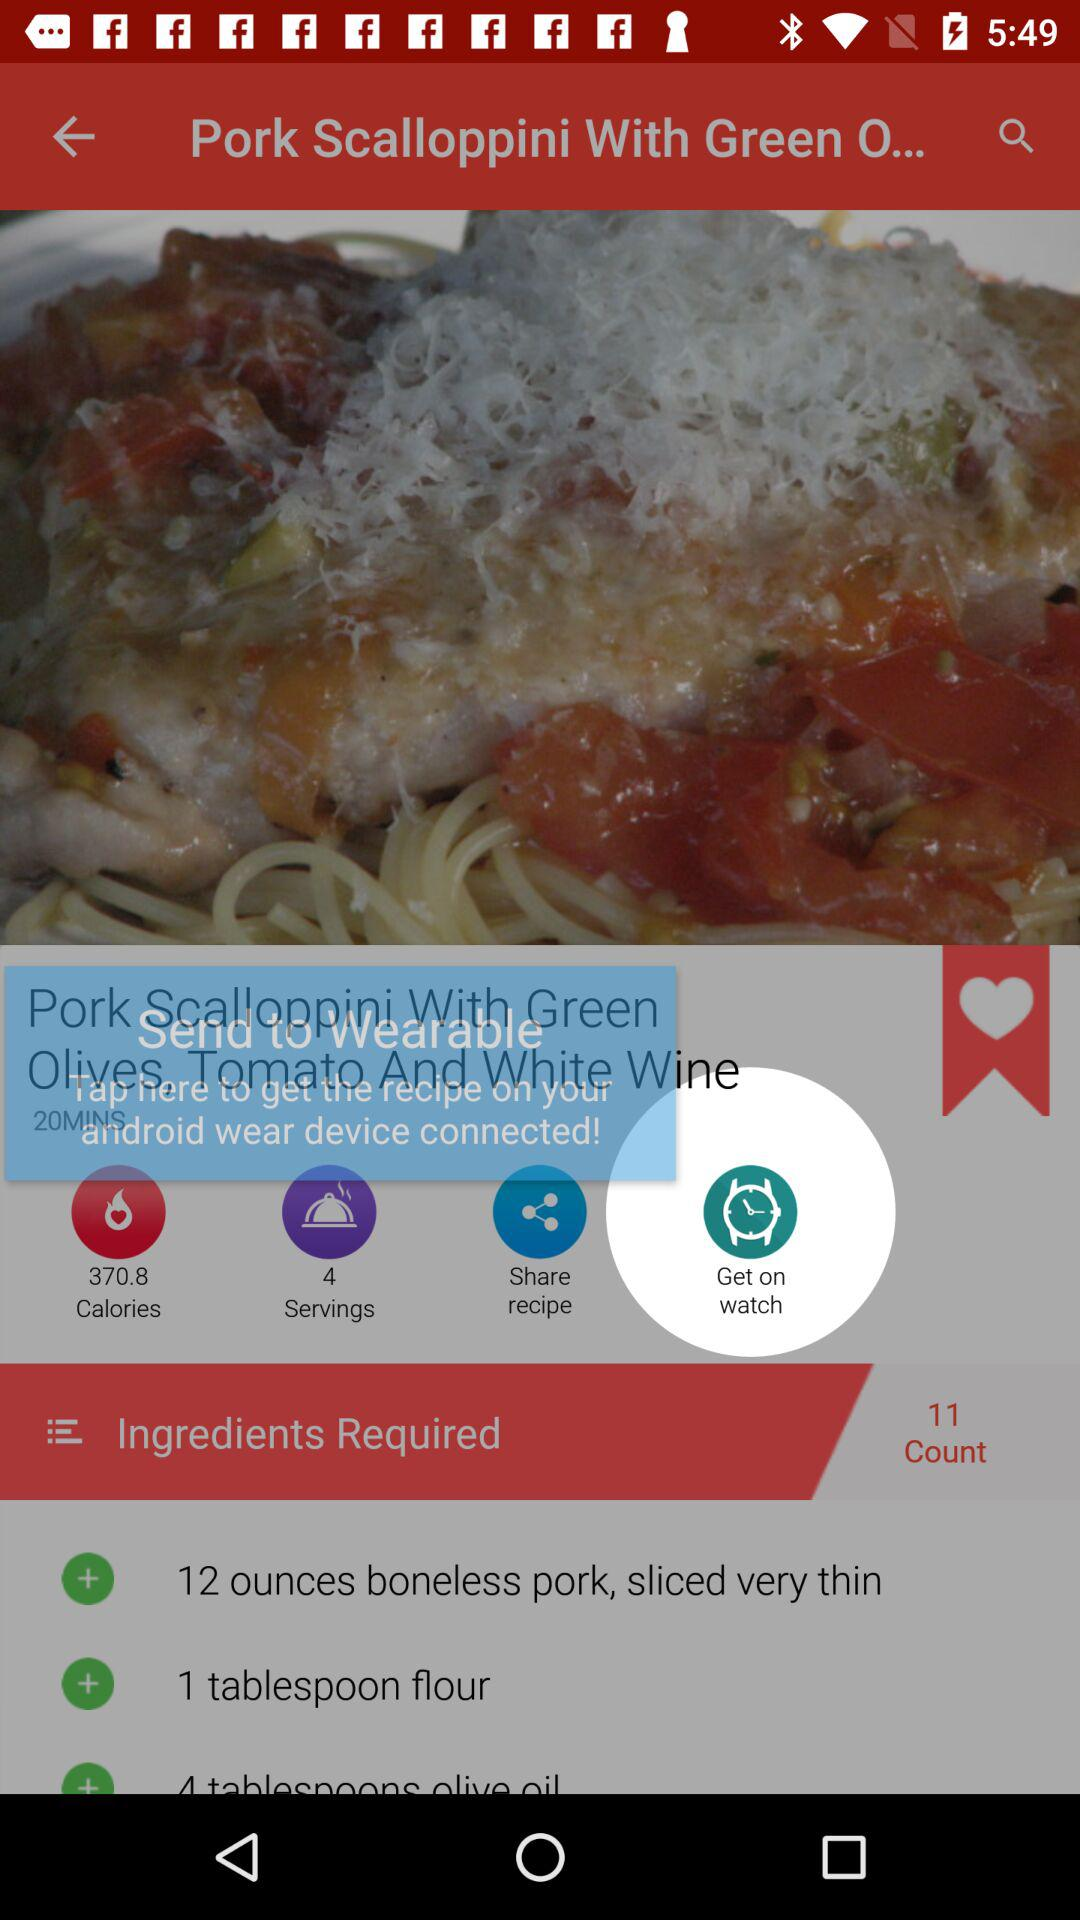What are the ingredients required? The ingredients required are 12 ounces boneless pork, sliced very thin and 1 tablespoon flour. 